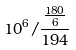Convert formula to latex. <formula><loc_0><loc_0><loc_500><loc_500>1 0 ^ { 6 } / \frac { \frac { 1 8 0 } { 6 } } { 1 9 4 }</formula> 